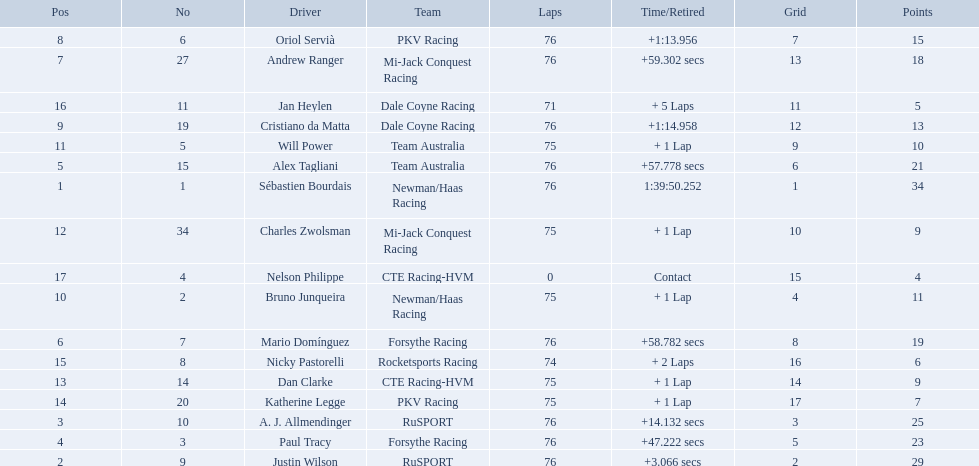What drivers took part in the 2006 tecate grand prix of monterrey? Sébastien Bourdais, Justin Wilson, A. J. Allmendinger, Paul Tracy, Alex Tagliani, Mario Domínguez, Andrew Ranger, Oriol Servià, Cristiano da Matta, Bruno Junqueira, Will Power, Charles Zwolsman, Dan Clarke, Katherine Legge, Nicky Pastorelli, Jan Heylen, Nelson Philippe. Which of those drivers scored the same amount of points as another driver? Charles Zwolsman, Dan Clarke. Who had the same amount of points as charles zwolsman? Dan Clarke. 